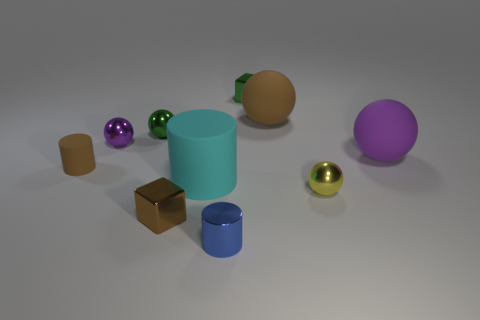Do the brown matte thing in front of the small green shiny sphere and the purple object that is on the right side of the tiny blue metal thing have the same size?
Ensure brevity in your answer.  No. Does the blue object have the same shape as the tiny purple metal thing?
Your response must be concise. No. What number of objects are either metal cubes that are on the left side of the cyan thing or blue metal things?
Ensure brevity in your answer.  2. Are there any small yellow objects of the same shape as the small blue object?
Your response must be concise. No. Are there the same number of tiny brown things to the right of the small blue object and large blue rubber cubes?
Provide a succinct answer. Yes. There is a tiny metallic thing that is the same color as the small matte object; what is its shape?
Make the answer very short. Cube. How many brown rubber spheres are the same size as the blue metal cylinder?
Your answer should be compact. 0. How many small cubes are in front of the purple metal object?
Give a very brief answer. 1. What is the small cylinder that is behind the cylinder that is to the right of the cyan matte cylinder made of?
Provide a short and direct response. Rubber. Are there any metal cubes of the same color as the tiny rubber object?
Make the answer very short. Yes. 